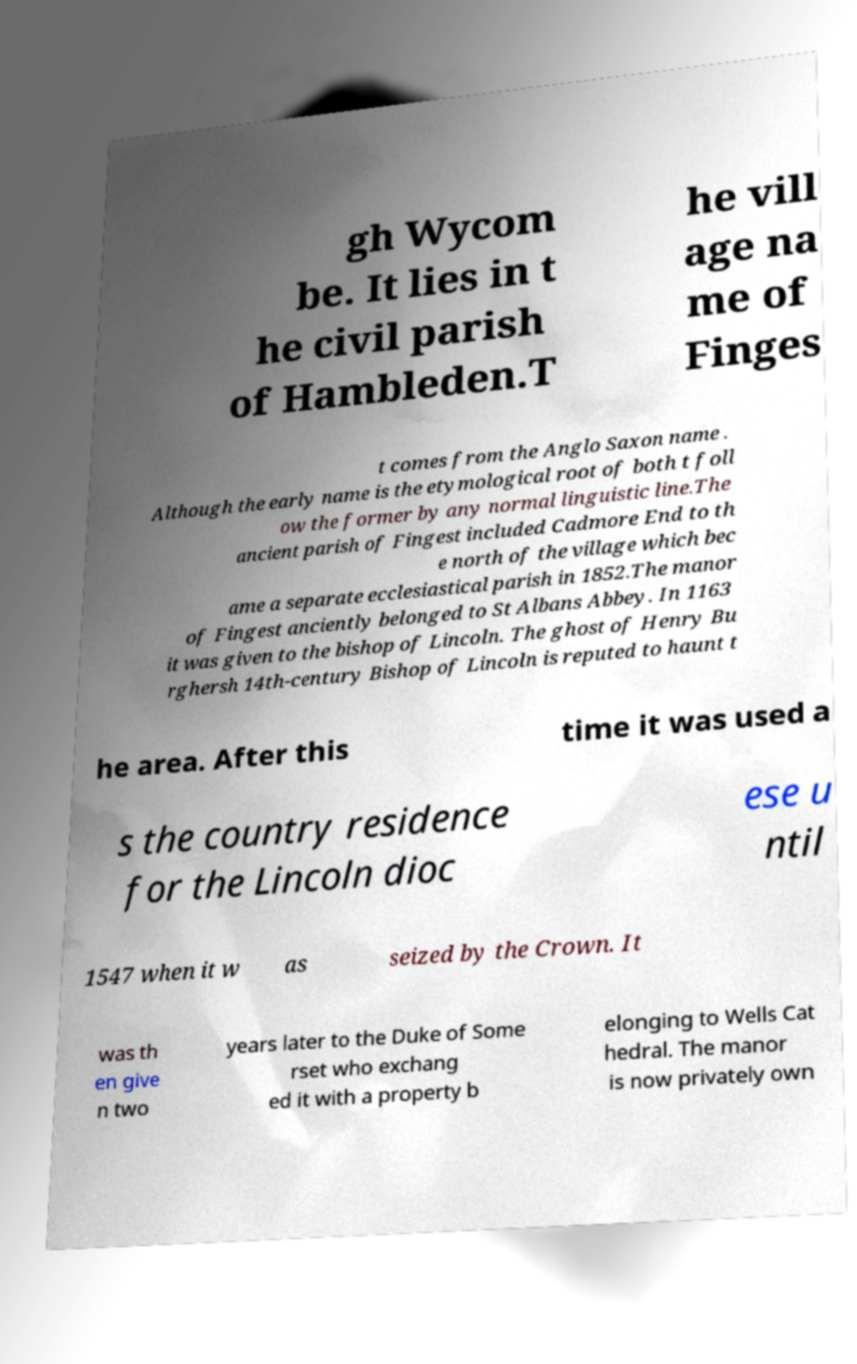For documentation purposes, I need the text within this image transcribed. Could you provide that? gh Wycom be. It lies in t he civil parish of Hambleden.T he vill age na me of Finges t comes from the Anglo Saxon name . Although the early name is the etymological root of both t foll ow the former by any normal linguistic line.The ancient parish of Fingest included Cadmore End to th e north of the village which bec ame a separate ecclesiastical parish in 1852.The manor of Fingest anciently belonged to St Albans Abbey. In 1163 it was given to the bishop of Lincoln. The ghost of Henry Bu rghersh 14th-century Bishop of Lincoln is reputed to haunt t he area. After this time it was used a s the country residence for the Lincoln dioc ese u ntil 1547 when it w as seized by the Crown. It was th en give n two years later to the Duke of Some rset who exchang ed it with a property b elonging to Wells Cat hedral. The manor is now privately own 